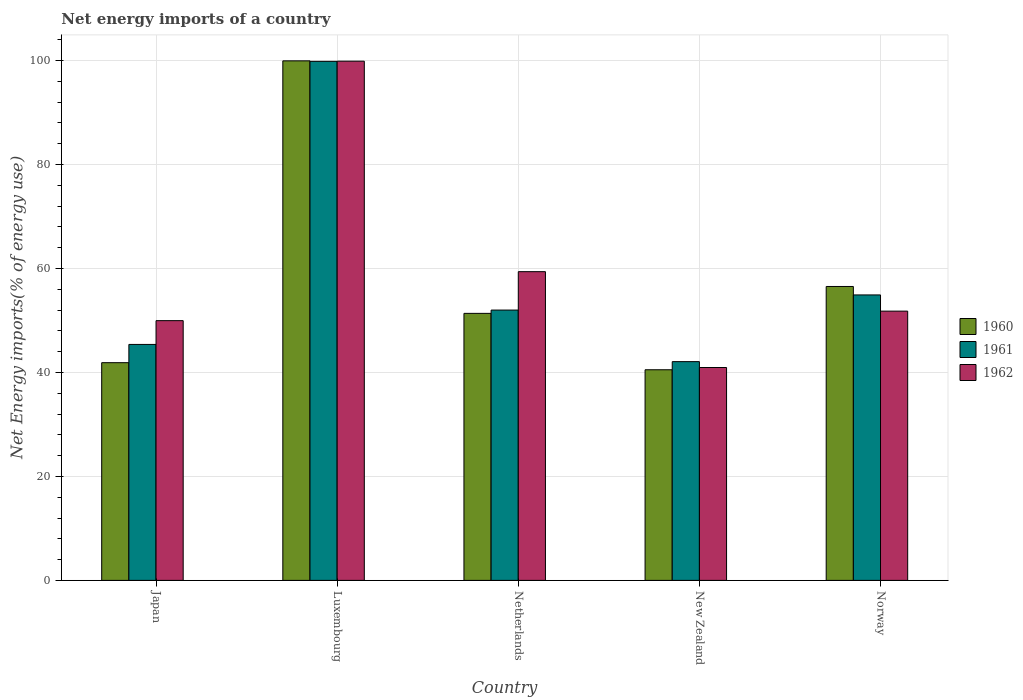How many groups of bars are there?
Provide a short and direct response. 5. Are the number of bars on each tick of the X-axis equal?
Keep it short and to the point. Yes. How many bars are there on the 1st tick from the left?
Offer a terse response. 3. How many bars are there on the 4th tick from the right?
Your answer should be compact. 3. What is the label of the 2nd group of bars from the left?
Make the answer very short. Luxembourg. What is the net energy imports in 1962 in New Zealand?
Your answer should be very brief. 40.95. Across all countries, what is the maximum net energy imports in 1960?
Offer a very short reply. 99.95. Across all countries, what is the minimum net energy imports in 1960?
Ensure brevity in your answer.  40.52. In which country was the net energy imports in 1960 maximum?
Your answer should be very brief. Luxembourg. In which country was the net energy imports in 1962 minimum?
Give a very brief answer. New Zealand. What is the total net energy imports in 1961 in the graph?
Offer a terse response. 294.25. What is the difference between the net energy imports in 1962 in New Zealand and that in Norway?
Provide a succinct answer. -10.85. What is the difference between the net energy imports in 1961 in Norway and the net energy imports in 1960 in Luxembourg?
Provide a succinct answer. -45.03. What is the average net energy imports in 1960 per country?
Provide a succinct answer. 58.05. What is the difference between the net energy imports of/in 1962 and net energy imports of/in 1961 in Luxembourg?
Ensure brevity in your answer.  0.03. What is the ratio of the net energy imports in 1961 in Japan to that in Norway?
Ensure brevity in your answer.  0.83. What is the difference between the highest and the second highest net energy imports in 1960?
Give a very brief answer. 5.17. What is the difference between the highest and the lowest net energy imports in 1961?
Offer a terse response. 57.77. Is it the case that in every country, the sum of the net energy imports in 1961 and net energy imports in 1962 is greater than the net energy imports in 1960?
Make the answer very short. Yes. How many countries are there in the graph?
Provide a succinct answer. 5. What is the difference between two consecutive major ticks on the Y-axis?
Your response must be concise. 20. Does the graph contain any zero values?
Provide a short and direct response. No. How many legend labels are there?
Provide a succinct answer. 3. What is the title of the graph?
Your response must be concise. Net energy imports of a country. What is the label or title of the Y-axis?
Keep it short and to the point. Net Energy imports(% of energy use). What is the Net Energy imports(% of energy use) of 1960 in Japan?
Make the answer very short. 41.88. What is the Net Energy imports(% of energy use) in 1961 in Japan?
Your answer should be compact. 45.39. What is the Net Energy imports(% of energy use) of 1962 in Japan?
Keep it short and to the point. 49.97. What is the Net Energy imports(% of energy use) of 1960 in Luxembourg?
Ensure brevity in your answer.  99.95. What is the Net Energy imports(% of energy use) of 1961 in Luxembourg?
Your response must be concise. 99.85. What is the Net Energy imports(% of energy use) of 1962 in Luxembourg?
Provide a succinct answer. 99.88. What is the Net Energy imports(% of energy use) in 1960 in Netherlands?
Offer a terse response. 51.37. What is the Net Energy imports(% of energy use) of 1961 in Netherlands?
Keep it short and to the point. 52. What is the Net Energy imports(% of energy use) of 1962 in Netherlands?
Make the answer very short. 59.39. What is the Net Energy imports(% of energy use) of 1960 in New Zealand?
Your response must be concise. 40.52. What is the Net Energy imports(% of energy use) in 1961 in New Zealand?
Offer a terse response. 42.08. What is the Net Energy imports(% of energy use) in 1962 in New Zealand?
Keep it short and to the point. 40.95. What is the Net Energy imports(% of energy use) of 1960 in Norway?
Provide a short and direct response. 56.54. What is the Net Energy imports(% of energy use) in 1961 in Norway?
Keep it short and to the point. 54.92. What is the Net Energy imports(% of energy use) in 1962 in Norway?
Ensure brevity in your answer.  51.8. Across all countries, what is the maximum Net Energy imports(% of energy use) of 1960?
Provide a succinct answer. 99.95. Across all countries, what is the maximum Net Energy imports(% of energy use) of 1961?
Offer a terse response. 99.85. Across all countries, what is the maximum Net Energy imports(% of energy use) in 1962?
Make the answer very short. 99.88. Across all countries, what is the minimum Net Energy imports(% of energy use) of 1960?
Make the answer very short. 40.52. Across all countries, what is the minimum Net Energy imports(% of energy use) of 1961?
Your answer should be very brief. 42.08. Across all countries, what is the minimum Net Energy imports(% of energy use) of 1962?
Make the answer very short. 40.95. What is the total Net Energy imports(% of energy use) of 1960 in the graph?
Provide a short and direct response. 290.26. What is the total Net Energy imports(% of energy use) in 1961 in the graph?
Offer a terse response. 294.25. What is the total Net Energy imports(% of energy use) in 1962 in the graph?
Your response must be concise. 302. What is the difference between the Net Energy imports(% of energy use) in 1960 in Japan and that in Luxembourg?
Ensure brevity in your answer.  -58.07. What is the difference between the Net Energy imports(% of energy use) of 1961 in Japan and that in Luxembourg?
Offer a very short reply. -54.46. What is the difference between the Net Energy imports(% of energy use) of 1962 in Japan and that in Luxembourg?
Your answer should be compact. -49.92. What is the difference between the Net Energy imports(% of energy use) in 1960 in Japan and that in Netherlands?
Provide a short and direct response. -9.49. What is the difference between the Net Energy imports(% of energy use) in 1961 in Japan and that in Netherlands?
Your response must be concise. -6.61. What is the difference between the Net Energy imports(% of energy use) of 1962 in Japan and that in Netherlands?
Ensure brevity in your answer.  -9.42. What is the difference between the Net Energy imports(% of energy use) of 1960 in Japan and that in New Zealand?
Offer a very short reply. 1.36. What is the difference between the Net Energy imports(% of energy use) in 1961 in Japan and that in New Zealand?
Your answer should be very brief. 3.31. What is the difference between the Net Energy imports(% of energy use) in 1962 in Japan and that in New Zealand?
Your answer should be compact. 9.02. What is the difference between the Net Energy imports(% of energy use) of 1960 in Japan and that in Norway?
Make the answer very short. -14.66. What is the difference between the Net Energy imports(% of energy use) of 1961 in Japan and that in Norway?
Give a very brief answer. -9.52. What is the difference between the Net Energy imports(% of energy use) in 1962 in Japan and that in Norway?
Keep it short and to the point. -1.83. What is the difference between the Net Energy imports(% of energy use) of 1960 in Luxembourg and that in Netherlands?
Your answer should be very brief. 48.58. What is the difference between the Net Energy imports(% of energy use) of 1961 in Luxembourg and that in Netherlands?
Provide a short and direct response. 47.85. What is the difference between the Net Energy imports(% of energy use) of 1962 in Luxembourg and that in Netherlands?
Keep it short and to the point. 40.49. What is the difference between the Net Energy imports(% of energy use) of 1960 in Luxembourg and that in New Zealand?
Your answer should be very brief. 59.43. What is the difference between the Net Energy imports(% of energy use) in 1961 in Luxembourg and that in New Zealand?
Keep it short and to the point. 57.77. What is the difference between the Net Energy imports(% of energy use) in 1962 in Luxembourg and that in New Zealand?
Provide a short and direct response. 58.93. What is the difference between the Net Energy imports(% of energy use) of 1960 in Luxembourg and that in Norway?
Your response must be concise. 43.41. What is the difference between the Net Energy imports(% of energy use) of 1961 in Luxembourg and that in Norway?
Offer a very short reply. 44.94. What is the difference between the Net Energy imports(% of energy use) of 1962 in Luxembourg and that in Norway?
Your response must be concise. 48.08. What is the difference between the Net Energy imports(% of energy use) of 1960 in Netherlands and that in New Zealand?
Your answer should be very brief. 10.85. What is the difference between the Net Energy imports(% of energy use) in 1961 in Netherlands and that in New Zealand?
Your answer should be very brief. 9.92. What is the difference between the Net Energy imports(% of energy use) of 1962 in Netherlands and that in New Zealand?
Provide a succinct answer. 18.44. What is the difference between the Net Energy imports(% of energy use) of 1960 in Netherlands and that in Norway?
Ensure brevity in your answer.  -5.17. What is the difference between the Net Energy imports(% of energy use) of 1961 in Netherlands and that in Norway?
Provide a succinct answer. -2.91. What is the difference between the Net Energy imports(% of energy use) of 1962 in Netherlands and that in Norway?
Your response must be concise. 7.59. What is the difference between the Net Energy imports(% of energy use) in 1960 in New Zealand and that in Norway?
Ensure brevity in your answer.  -16.02. What is the difference between the Net Energy imports(% of energy use) in 1961 in New Zealand and that in Norway?
Give a very brief answer. -12.83. What is the difference between the Net Energy imports(% of energy use) of 1962 in New Zealand and that in Norway?
Offer a very short reply. -10.85. What is the difference between the Net Energy imports(% of energy use) in 1960 in Japan and the Net Energy imports(% of energy use) in 1961 in Luxembourg?
Offer a terse response. -57.97. What is the difference between the Net Energy imports(% of energy use) in 1960 in Japan and the Net Energy imports(% of energy use) in 1962 in Luxembourg?
Provide a short and direct response. -58. What is the difference between the Net Energy imports(% of energy use) of 1961 in Japan and the Net Energy imports(% of energy use) of 1962 in Luxembourg?
Your answer should be compact. -54.49. What is the difference between the Net Energy imports(% of energy use) of 1960 in Japan and the Net Energy imports(% of energy use) of 1961 in Netherlands?
Ensure brevity in your answer.  -10.12. What is the difference between the Net Energy imports(% of energy use) in 1960 in Japan and the Net Energy imports(% of energy use) in 1962 in Netherlands?
Your answer should be compact. -17.51. What is the difference between the Net Energy imports(% of energy use) in 1961 in Japan and the Net Energy imports(% of energy use) in 1962 in Netherlands?
Your answer should be very brief. -14. What is the difference between the Net Energy imports(% of energy use) of 1960 in Japan and the Net Energy imports(% of energy use) of 1961 in New Zealand?
Your response must be concise. -0.2. What is the difference between the Net Energy imports(% of energy use) of 1960 in Japan and the Net Energy imports(% of energy use) of 1962 in New Zealand?
Ensure brevity in your answer.  0.93. What is the difference between the Net Energy imports(% of energy use) in 1961 in Japan and the Net Energy imports(% of energy use) in 1962 in New Zealand?
Provide a short and direct response. 4.44. What is the difference between the Net Energy imports(% of energy use) of 1960 in Japan and the Net Energy imports(% of energy use) of 1961 in Norway?
Provide a short and direct response. -13.03. What is the difference between the Net Energy imports(% of energy use) in 1960 in Japan and the Net Energy imports(% of energy use) in 1962 in Norway?
Provide a short and direct response. -9.92. What is the difference between the Net Energy imports(% of energy use) in 1961 in Japan and the Net Energy imports(% of energy use) in 1962 in Norway?
Make the answer very short. -6.41. What is the difference between the Net Energy imports(% of energy use) in 1960 in Luxembourg and the Net Energy imports(% of energy use) in 1961 in Netherlands?
Your response must be concise. 47.94. What is the difference between the Net Energy imports(% of energy use) in 1960 in Luxembourg and the Net Energy imports(% of energy use) in 1962 in Netherlands?
Your response must be concise. 40.56. What is the difference between the Net Energy imports(% of energy use) of 1961 in Luxembourg and the Net Energy imports(% of energy use) of 1962 in Netherlands?
Ensure brevity in your answer.  40.46. What is the difference between the Net Energy imports(% of energy use) in 1960 in Luxembourg and the Net Energy imports(% of energy use) in 1961 in New Zealand?
Your answer should be compact. 57.87. What is the difference between the Net Energy imports(% of energy use) of 1960 in Luxembourg and the Net Energy imports(% of energy use) of 1962 in New Zealand?
Your answer should be compact. 58.99. What is the difference between the Net Energy imports(% of energy use) of 1961 in Luxembourg and the Net Energy imports(% of energy use) of 1962 in New Zealand?
Give a very brief answer. 58.9. What is the difference between the Net Energy imports(% of energy use) in 1960 in Luxembourg and the Net Energy imports(% of energy use) in 1961 in Norway?
Ensure brevity in your answer.  45.03. What is the difference between the Net Energy imports(% of energy use) of 1960 in Luxembourg and the Net Energy imports(% of energy use) of 1962 in Norway?
Make the answer very short. 48.15. What is the difference between the Net Energy imports(% of energy use) of 1961 in Luxembourg and the Net Energy imports(% of energy use) of 1962 in Norway?
Give a very brief answer. 48.05. What is the difference between the Net Energy imports(% of energy use) in 1960 in Netherlands and the Net Energy imports(% of energy use) in 1961 in New Zealand?
Provide a short and direct response. 9.29. What is the difference between the Net Energy imports(% of energy use) in 1960 in Netherlands and the Net Energy imports(% of energy use) in 1962 in New Zealand?
Your answer should be very brief. 10.42. What is the difference between the Net Energy imports(% of energy use) in 1961 in Netherlands and the Net Energy imports(% of energy use) in 1962 in New Zealand?
Provide a succinct answer. 11.05. What is the difference between the Net Energy imports(% of energy use) of 1960 in Netherlands and the Net Energy imports(% of energy use) of 1961 in Norway?
Your answer should be compact. -3.55. What is the difference between the Net Energy imports(% of energy use) in 1960 in Netherlands and the Net Energy imports(% of energy use) in 1962 in Norway?
Offer a very short reply. -0.43. What is the difference between the Net Energy imports(% of energy use) of 1961 in Netherlands and the Net Energy imports(% of energy use) of 1962 in Norway?
Give a very brief answer. 0.2. What is the difference between the Net Energy imports(% of energy use) of 1960 in New Zealand and the Net Energy imports(% of energy use) of 1961 in Norway?
Your response must be concise. -14.39. What is the difference between the Net Energy imports(% of energy use) of 1960 in New Zealand and the Net Energy imports(% of energy use) of 1962 in Norway?
Ensure brevity in your answer.  -11.28. What is the difference between the Net Energy imports(% of energy use) in 1961 in New Zealand and the Net Energy imports(% of energy use) in 1962 in Norway?
Ensure brevity in your answer.  -9.72. What is the average Net Energy imports(% of energy use) in 1960 per country?
Your answer should be very brief. 58.05. What is the average Net Energy imports(% of energy use) in 1961 per country?
Keep it short and to the point. 58.85. What is the average Net Energy imports(% of energy use) in 1962 per country?
Your answer should be compact. 60.4. What is the difference between the Net Energy imports(% of energy use) in 1960 and Net Energy imports(% of energy use) in 1961 in Japan?
Keep it short and to the point. -3.51. What is the difference between the Net Energy imports(% of energy use) of 1960 and Net Energy imports(% of energy use) of 1962 in Japan?
Your answer should be compact. -8.09. What is the difference between the Net Energy imports(% of energy use) of 1961 and Net Energy imports(% of energy use) of 1962 in Japan?
Provide a short and direct response. -4.57. What is the difference between the Net Energy imports(% of energy use) in 1960 and Net Energy imports(% of energy use) in 1961 in Luxembourg?
Offer a very short reply. 0.09. What is the difference between the Net Energy imports(% of energy use) of 1960 and Net Energy imports(% of energy use) of 1962 in Luxembourg?
Ensure brevity in your answer.  0.06. What is the difference between the Net Energy imports(% of energy use) in 1961 and Net Energy imports(% of energy use) in 1962 in Luxembourg?
Give a very brief answer. -0.03. What is the difference between the Net Energy imports(% of energy use) in 1960 and Net Energy imports(% of energy use) in 1961 in Netherlands?
Make the answer very short. -0.64. What is the difference between the Net Energy imports(% of energy use) in 1960 and Net Energy imports(% of energy use) in 1962 in Netherlands?
Your answer should be very brief. -8.02. What is the difference between the Net Energy imports(% of energy use) of 1961 and Net Energy imports(% of energy use) of 1962 in Netherlands?
Make the answer very short. -7.39. What is the difference between the Net Energy imports(% of energy use) of 1960 and Net Energy imports(% of energy use) of 1961 in New Zealand?
Ensure brevity in your answer.  -1.56. What is the difference between the Net Energy imports(% of energy use) in 1960 and Net Energy imports(% of energy use) in 1962 in New Zealand?
Keep it short and to the point. -0.43. What is the difference between the Net Energy imports(% of energy use) in 1961 and Net Energy imports(% of energy use) in 1962 in New Zealand?
Offer a very short reply. 1.13. What is the difference between the Net Energy imports(% of energy use) of 1960 and Net Energy imports(% of energy use) of 1961 in Norway?
Provide a short and direct response. 1.62. What is the difference between the Net Energy imports(% of energy use) in 1960 and Net Energy imports(% of energy use) in 1962 in Norway?
Offer a terse response. 4.74. What is the difference between the Net Energy imports(% of energy use) in 1961 and Net Energy imports(% of energy use) in 1962 in Norway?
Keep it short and to the point. 3.12. What is the ratio of the Net Energy imports(% of energy use) in 1960 in Japan to that in Luxembourg?
Keep it short and to the point. 0.42. What is the ratio of the Net Energy imports(% of energy use) in 1961 in Japan to that in Luxembourg?
Offer a terse response. 0.45. What is the ratio of the Net Energy imports(% of energy use) of 1962 in Japan to that in Luxembourg?
Your answer should be very brief. 0.5. What is the ratio of the Net Energy imports(% of energy use) in 1960 in Japan to that in Netherlands?
Offer a very short reply. 0.82. What is the ratio of the Net Energy imports(% of energy use) in 1961 in Japan to that in Netherlands?
Give a very brief answer. 0.87. What is the ratio of the Net Energy imports(% of energy use) in 1962 in Japan to that in Netherlands?
Provide a succinct answer. 0.84. What is the ratio of the Net Energy imports(% of energy use) in 1960 in Japan to that in New Zealand?
Offer a very short reply. 1.03. What is the ratio of the Net Energy imports(% of energy use) of 1961 in Japan to that in New Zealand?
Offer a very short reply. 1.08. What is the ratio of the Net Energy imports(% of energy use) in 1962 in Japan to that in New Zealand?
Your answer should be very brief. 1.22. What is the ratio of the Net Energy imports(% of energy use) in 1960 in Japan to that in Norway?
Provide a short and direct response. 0.74. What is the ratio of the Net Energy imports(% of energy use) in 1961 in Japan to that in Norway?
Provide a succinct answer. 0.83. What is the ratio of the Net Energy imports(% of energy use) of 1962 in Japan to that in Norway?
Offer a very short reply. 0.96. What is the ratio of the Net Energy imports(% of energy use) of 1960 in Luxembourg to that in Netherlands?
Provide a short and direct response. 1.95. What is the ratio of the Net Energy imports(% of energy use) of 1961 in Luxembourg to that in Netherlands?
Offer a terse response. 1.92. What is the ratio of the Net Energy imports(% of energy use) in 1962 in Luxembourg to that in Netherlands?
Your response must be concise. 1.68. What is the ratio of the Net Energy imports(% of energy use) in 1960 in Luxembourg to that in New Zealand?
Give a very brief answer. 2.47. What is the ratio of the Net Energy imports(% of energy use) in 1961 in Luxembourg to that in New Zealand?
Your answer should be very brief. 2.37. What is the ratio of the Net Energy imports(% of energy use) of 1962 in Luxembourg to that in New Zealand?
Give a very brief answer. 2.44. What is the ratio of the Net Energy imports(% of energy use) of 1960 in Luxembourg to that in Norway?
Make the answer very short. 1.77. What is the ratio of the Net Energy imports(% of energy use) of 1961 in Luxembourg to that in Norway?
Give a very brief answer. 1.82. What is the ratio of the Net Energy imports(% of energy use) in 1962 in Luxembourg to that in Norway?
Offer a terse response. 1.93. What is the ratio of the Net Energy imports(% of energy use) in 1960 in Netherlands to that in New Zealand?
Ensure brevity in your answer.  1.27. What is the ratio of the Net Energy imports(% of energy use) of 1961 in Netherlands to that in New Zealand?
Your response must be concise. 1.24. What is the ratio of the Net Energy imports(% of energy use) of 1962 in Netherlands to that in New Zealand?
Offer a very short reply. 1.45. What is the ratio of the Net Energy imports(% of energy use) in 1960 in Netherlands to that in Norway?
Your answer should be compact. 0.91. What is the ratio of the Net Energy imports(% of energy use) in 1961 in Netherlands to that in Norway?
Provide a succinct answer. 0.95. What is the ratio of the Net Energy imports(% of energy use) in 1962 in Netherlands to that in Norway?
Keep it short and to the point. 1.15. What is the ratio of the Net Energy imports(% of energy use) of 1960 in New Zealand to that in Norway?
Offer a very short reply. 0.72. What is the ratio of the Net Energy imports(% of energy use) of 1961 in New Zealand to that in Norway?
Keep it short and to the point. 0.77. What is the ratio of the Net Energy imports(% of energy use) of 1962 in New Zealand to that in Norway?
Your answer should be compact. 0.79. What is the difference between the highest and the second highest Net Energy imports(% of energy use) in 1960?
Provide a succinct answer. 43.41. What is the difference between the highest and the second highest Net Energy imports(% of energy use) of 1961?
Offer a terse response. 44.94. What is the difference between the highest and the second highest Net Energy imports(% of energy use) of 1962?
Provide a short and direct response. 40.49. What is the difference between the highest and the lowest Net Energy imports(% of energy use) in 1960?
Make the answer very short. 59.43. What is the difference between the highest and the lowest Net Energy imports(% of energy use) in 1961?
Provide a succinct answer. 57.77. What is the difference between the highest and the lowest Net Energy imports(% of energy use) of 1962?
Provide a short and direct response. 58.93. 